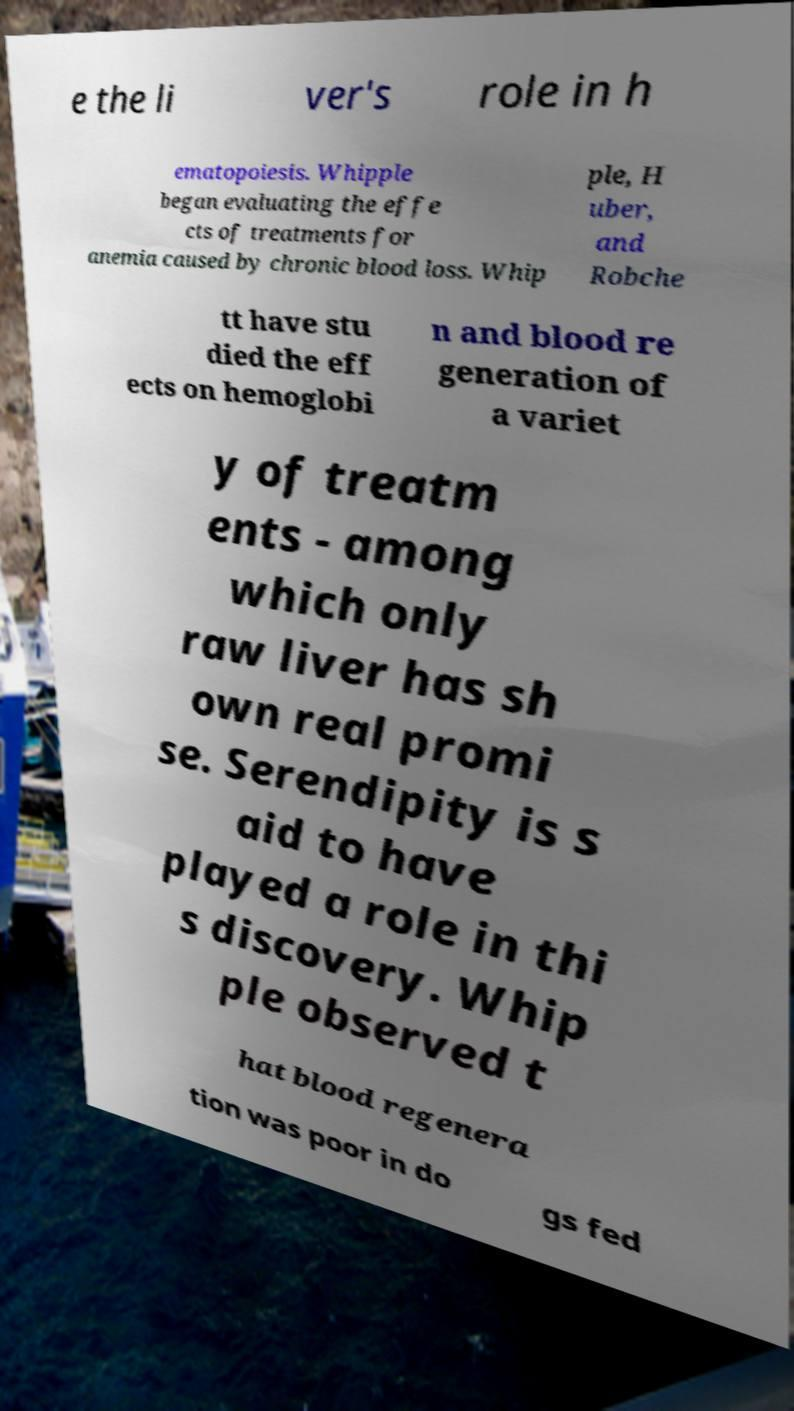What messages or text are displayed in this image? I need them in a readable, typed format. e the li ver's role in h ematopoiesis. Whipple began evaluating the effe cts of treatments for anemia caused by chronic blood loss. Whip ple, H uber, and Robche tt have stu died the eff ects on hemoglobi n and blood re generation of a variet y of treatm ents - among which only raw liver has sh own real promi se. Serendipity is s aid to have played a role in thi s discovery. Whip ple observed t hat blood regenera tion was poor in do gs fed 